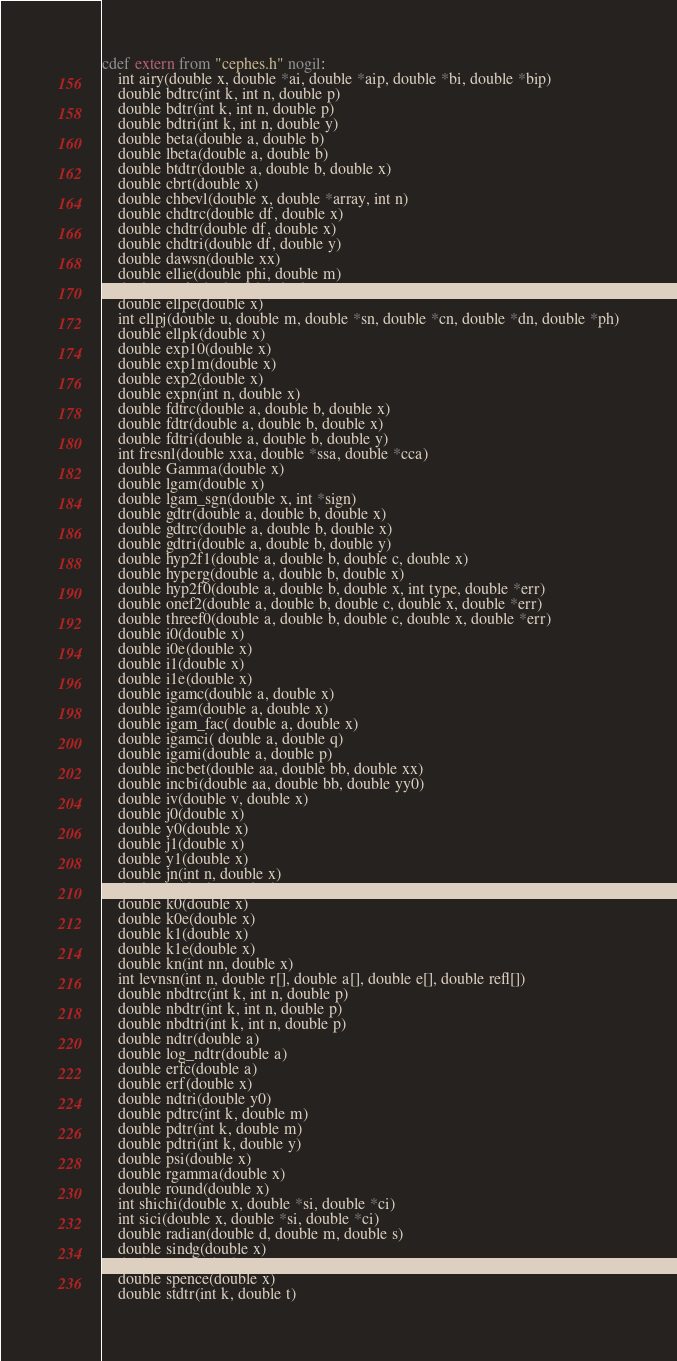<code> <loc_0><loc_0><loc_500><loc_500><_Cython_>cdef extern from "cephes.h" nogil:
    int airy(double x, double *ai, double *aip, double *bi, double *bip)
    double bdtrc(int k, int n, double p)
    double bdtr(int k, int n, double p)
    double bdtri(int k, int n, double y)
    double beta(double a, double b)
    double lbeta(double a, double b)
    double btdtr(double a, double b, double x)
    double cbrt(double x)
    double chbevl(double x, double *array, int n)
    double chdtrc(double df, double x)
    double chdtr(double df, double x)
    double chdtri(double df, double y)
    double dawsn(double xx)
    double ellie(double phi, double m)
    double ellik(double phi, double m)
    double ellpe(double x)
    int ellpj(double u, double m, double *sn, double *cn, double *dn, double *ph)
    double ellpk(double x)
    double exp10(double x)
    double exp1m(double x)
    double exp2(double x)
    double expn(int n, double x)
    double fdtrc(double a, double b, double x)
    double fdtr(double a, double b, double x)
    double fdtri(double a, double b, double y)
    int fresnl(double xxa, double *ssa, double *cca)
    double Gamma(double x)
    double lgam(double x)
    double lgam_sgn(double x, int *sign)
    double gdtr(double a, double b, double x)
    double gdtrc(double a, double b, double x)
    double gdtri(double a, double b, double y)
    double hyp2f1(double a, double b, double c, double x)
    double hyperg(double a, double b, double x)
    double hyp2f0(double a, double b, double x, int type, double *err)
    double onef2(double a, double b, double c, double x, double *err)
    double threef0(double a, double b, double c, double x, double *err)
    double i0(double x)
    double i0e(double x)
    double i1(double x)
    double i1e(double x)
    double igamc(double a, double x)
    double igam(double a, double x)
    double igam_fac( double a, double x)
    double igamci( double a, double q)
    double igami(double a, double p)
    double incbet(double aa, double bb, double xx)
    double incbi(double aa, double bb, double yy0)
    double iv(double v, double x)
    double j0(double x)
    double y0(double x)
    double j1(double x)
    double y1(double x)
    double jn(int n, double x)
    double jv(double n, double x)
    double k0(double x)
    double k0e(double x)
    double k1(double x)
    double k1e(double x)
    double kn(int nn, double x)
    int levnsn(int n, double r[], double a[], double e[], double refl[])
    double nbdtrc(int k, int n, double p)
    double nbdtr(int k, int n, double p)
    double nbdtri(int k, int n, double p)
    double ndtr(double a)
    double log_ndtr(double a)
    double erfc(double a)
    double erf(double x)
    double ndtri(double y0)
    double pdtrc(int k, double m)
    double pdtr(int k, double m)
    double pdtri(int k, double y)
    double psi(double x)
    double rgamma(double x)
    double round(double x)
    int shichi(double x, double *si, double *ci)
    int sici(double x, double *si, double *ci)
    double radian(double d, double m, double s)
    double sindg(double x)
    double cosdg(double x)
    double spence(double x)
    double stdtr(int k, double t)</code> 